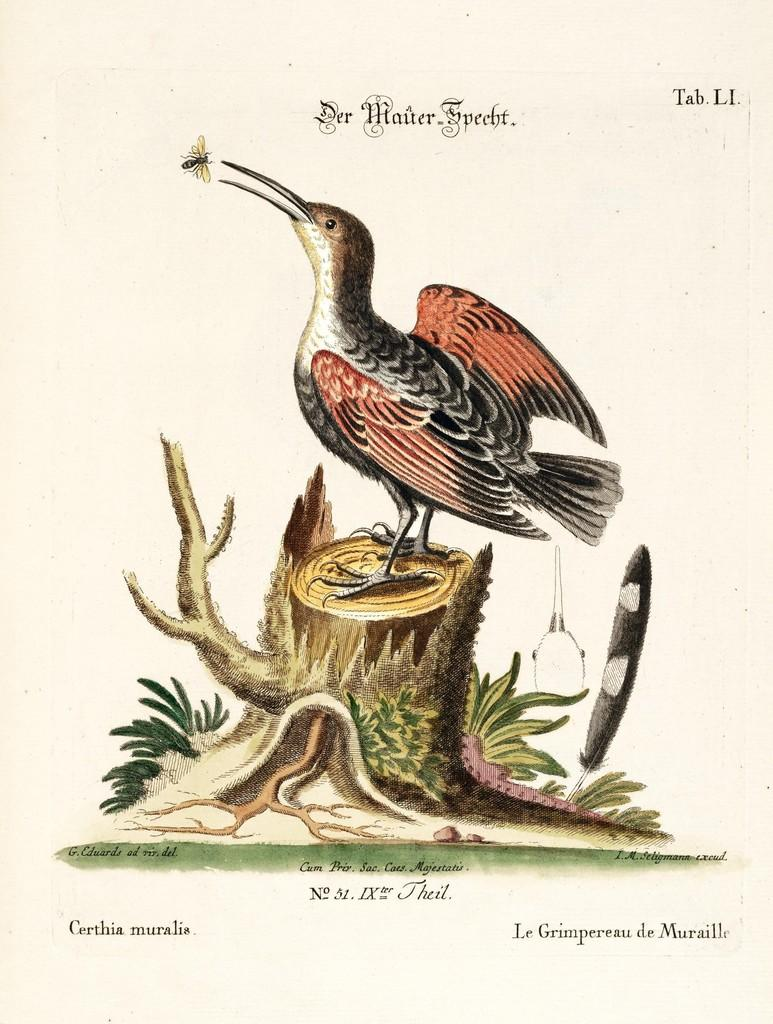What is depicted on the paper in the image? The paper contains an image of a bird. What is the bird doing in the image? The bird is standing on a tree trunk in the image. What other living organism can be seen in the image? There is an insect in the image. What type of vegetation is present in the image? There are plants in the image. What else is written or printed on the paper? There are words on the paper. What type of dress is the horse wearing in the image? There is no horse or dress present in the image. How many beans are visible in the image? There are no beans present in the image. 